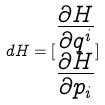<formula> <loc_0><loc_0><loc_500><loc_500>d H = [ \begin{matrix} \frac { \partial H } { \partial q ^ { i } } \\ \frac { \partial H } { \partial p _ { i } } \end{matrix} ]</formula> 